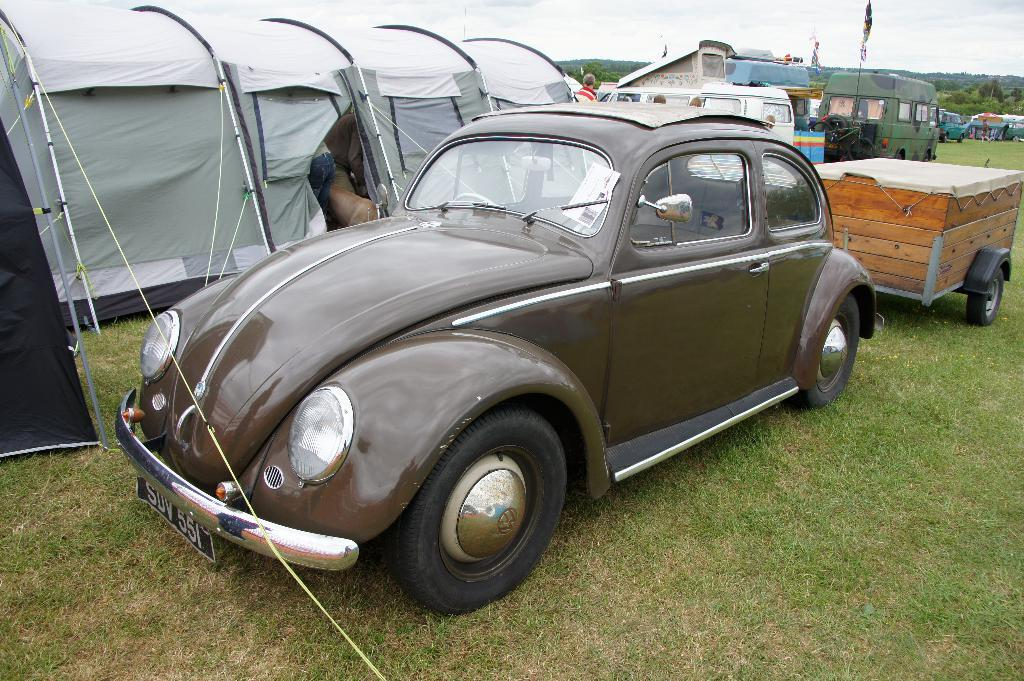What types of objects are present in the image? There are vehicles and tents in the image. What are the people in the image doing? The people in the image are on the grass. What can be seen in the background of the image? There are trees and the sky visible in the background of the image. What type of line can be seen connecting the vehicles in the image? There is no line connecting the vehicles in the image. How does the dust affect the visibility of the tents in the image? There is no mention of dust in the image, so its effect on the visibility of the tents cannot be determined. 